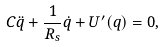Convert formula to latex. <formula><loc_0><loc_0><loc_500><loc_500>C \ddot { q } + \frac { 1 } { R _ { s } } \dot { q } + U ^ { \prime } ( q ) = 0 ,</formula> 